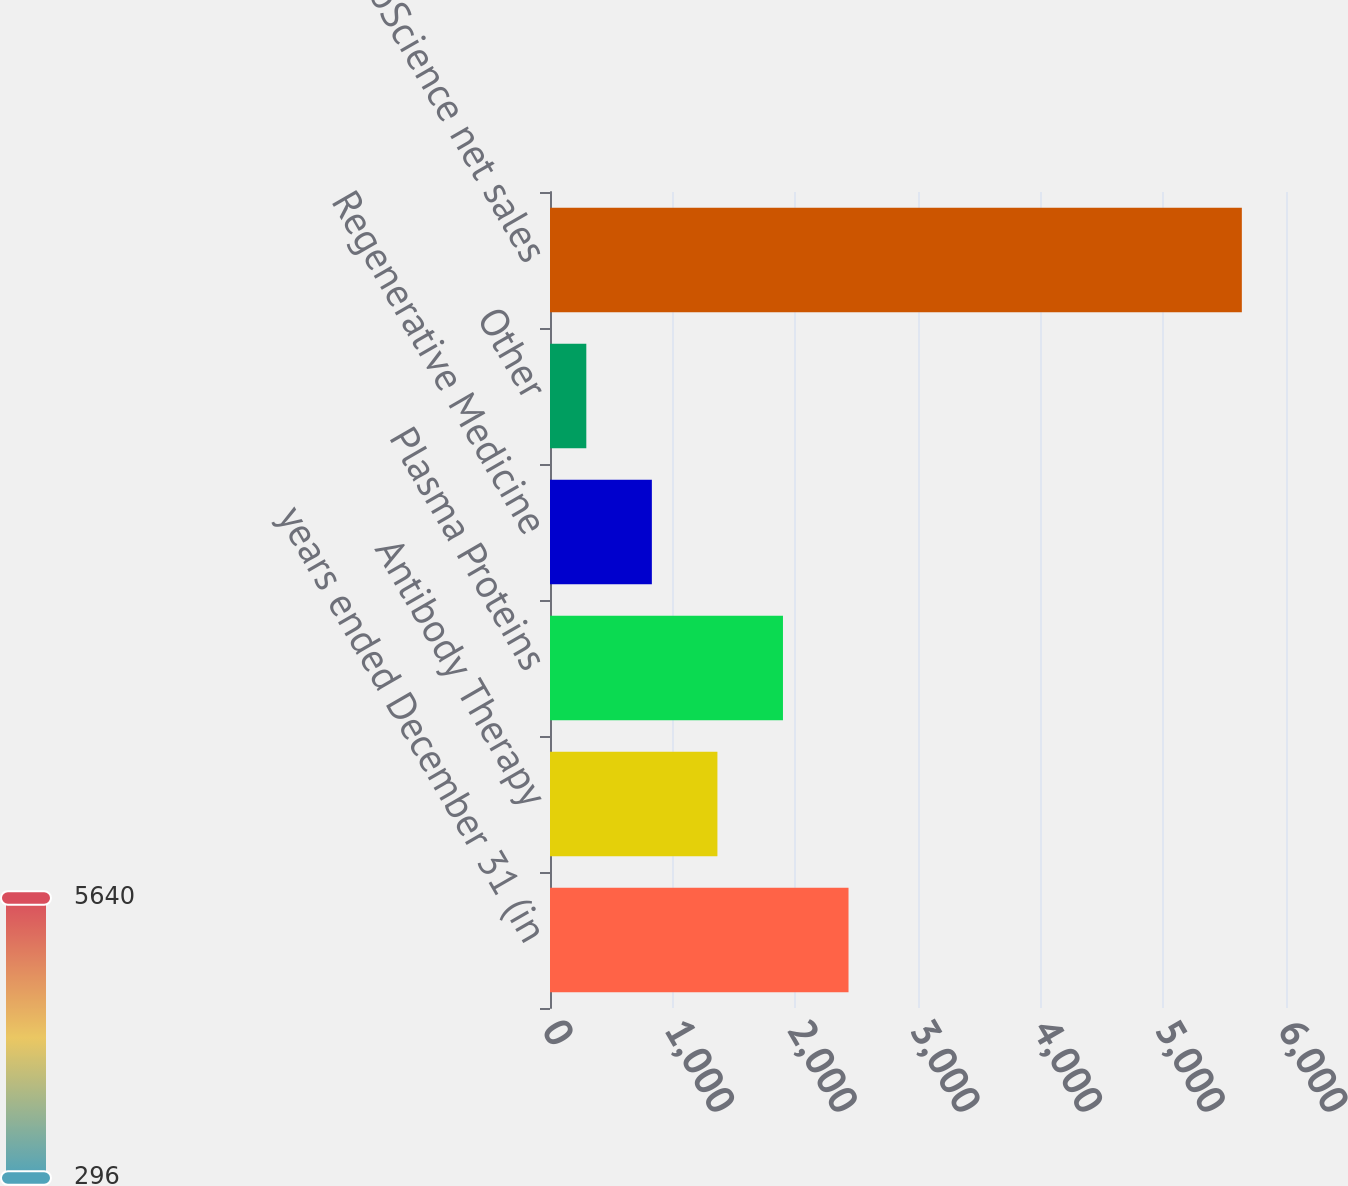<chart> <loc_0><loc_0><loc_500><loc_500><bar_chart><fcel>years ended December 31 (in<fcel>Antibody Therapy<fcel>Plasma Proteins<fcel>Regenerative Medicine<fcel>Other<fcel>Total BioScience net sales<nl><fcel>2433.6<fcel>1364.8<fcel>1899.2<fcel>830.4<fcel>296<fcel>5640<nl></chart> 